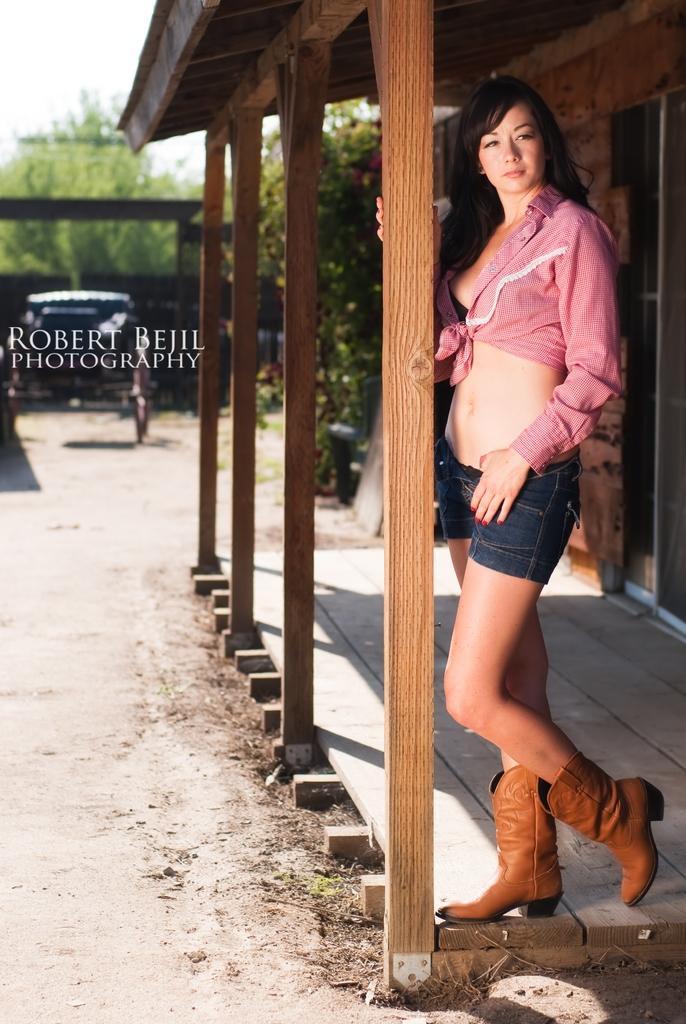Can you describe this image briefly? In this image I can see a person is wearing pink top and jeans. Back I can a house,trees,vehicle and shed. The sky is white color. 